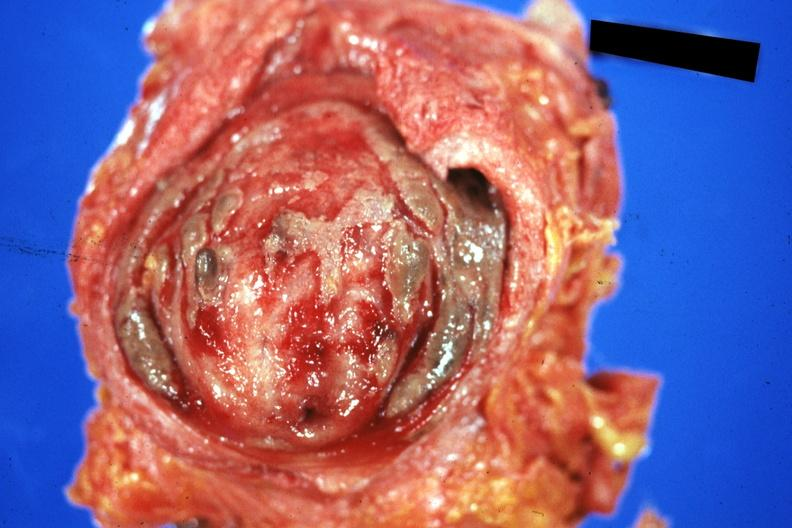s polycystic disease infant present?
Answer the question using a single word or phrase. No 